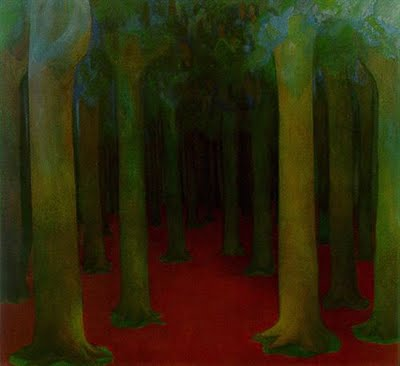Write a detailed description of the given image. The image presents an oil painting executed in an impressionistic style, focusing on a tranquil forest scene. The artist uses a limited but bold palette dominated by different shades of green and striking red, creating a vivid contrast that draws the viewer’s eye along the forest floor. The trees are depicted with elongated, slender trunks and a canopy lush with green leaves, suggestive of tall, mature timber. The background features multiple layers of green, conveying depth and density in the woods. The forest floor is an arresting red, possibly symbolizing a rich undergrowth or a metaphorical path leading into the depths of the forest. This choice of color could evoke feelings of mystery or enchantment. The brushwork is loose and fluid, enhancing the feeling of natural growth and organic movement, inviting the viewer to contemplate the natural world's beauty and serenity. 